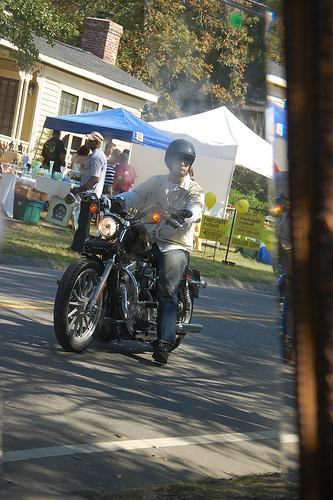Describe the prominent structures on the roof of the yellow house. A brick chimney and an open porch are noticeable structures on the roof of the yellow house. Identify the primary object used for protection on the head of the motorbike rider. A black motorcycle safety helmet with chin strap is worn by the rider to protect his head. Mention two articles of clothing the man on the motorcycle is wearing and describe their colors. The man is wearing a black helmet and blue jeans while riding the motorcycle. What color are the two canopies visible in the yard and state their purpose in the image? There is a blue canopy being used as an open shelter for a yard sale and a white canopy style shelter placed in the yard. List two details about the balloons in the image and state where they are located.  The balloons are yellow and attached to a sign on the side of the road, near the yard sale. Which objects, related to the motorcycle, are specifically mentioned in terms of color and describe one of their unique features. A black colored motorcycle and silver motorcycle exhaust system are mentioned. The black motorcycle has a turned on headlight, illuminating the road. Describe the features and colors of the house in the background. A yellow colored home with yellow trim has a brick chimney on its roof top, an open porch, windows, and a door, with a tree behind it. List two distinctive lines that can be noticed on the pavement in the image. A white line and yellow street lines are painted on the asphalt pavement. What color is the tent in the image and what activity is it associated with?  The tent is blue and is being used as an open shelter for a yard sale. What is the color and purpose of the line present on the street? The white line on the pavement assists with traffic navigation and separation, while the yellow lines designate where vehicles should not cross or park. 